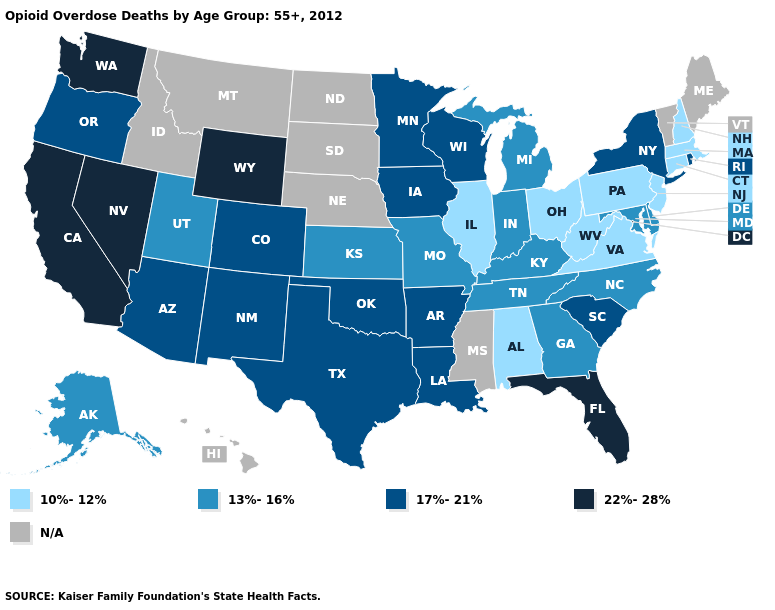What is the lowest value in the West?
Be succinct. 13%-16%. What is the value of Virginia?
Concise answer only. 10%-12%. Name the states that have a value in the range 22%-28%?
Be succinct. California, Florida, Nevada, Washington, Wyoming. Is the legend a continuous bar?
Short answer required. No. Which states have the lowest value in the South?
Keep it brief. Alabama, Virginia, West Virginia. Which states have the lowest value in the South?
Short answer required. Alabama, Virginia, West Virginia. What is the value of Illinois?
Write a very short answer. 10%-12%. Among the states that border Connecticut , does Rhode Island have the lowest value?
Keep it brief. No. Name the states that have a value in the range 13%-16%?
Be succinct. Alaska, Delaware, Georgia, Indiana, Kansas, Kentucky, Maryland, Michigan, Missouri, North Carolina, Tennessee, Utah. What is the value of Oregon?
Short answer required. 17%-21%. What is the value of North Carolina?
Concise answer only. 13%-16%. What is the value of Florida?
Quick response, please. 22%-28%. What is the highest value in the USA?
Quick response, please. 22%-28%. What is the lowest value in the West?
Be succinct. 13%-16%. 